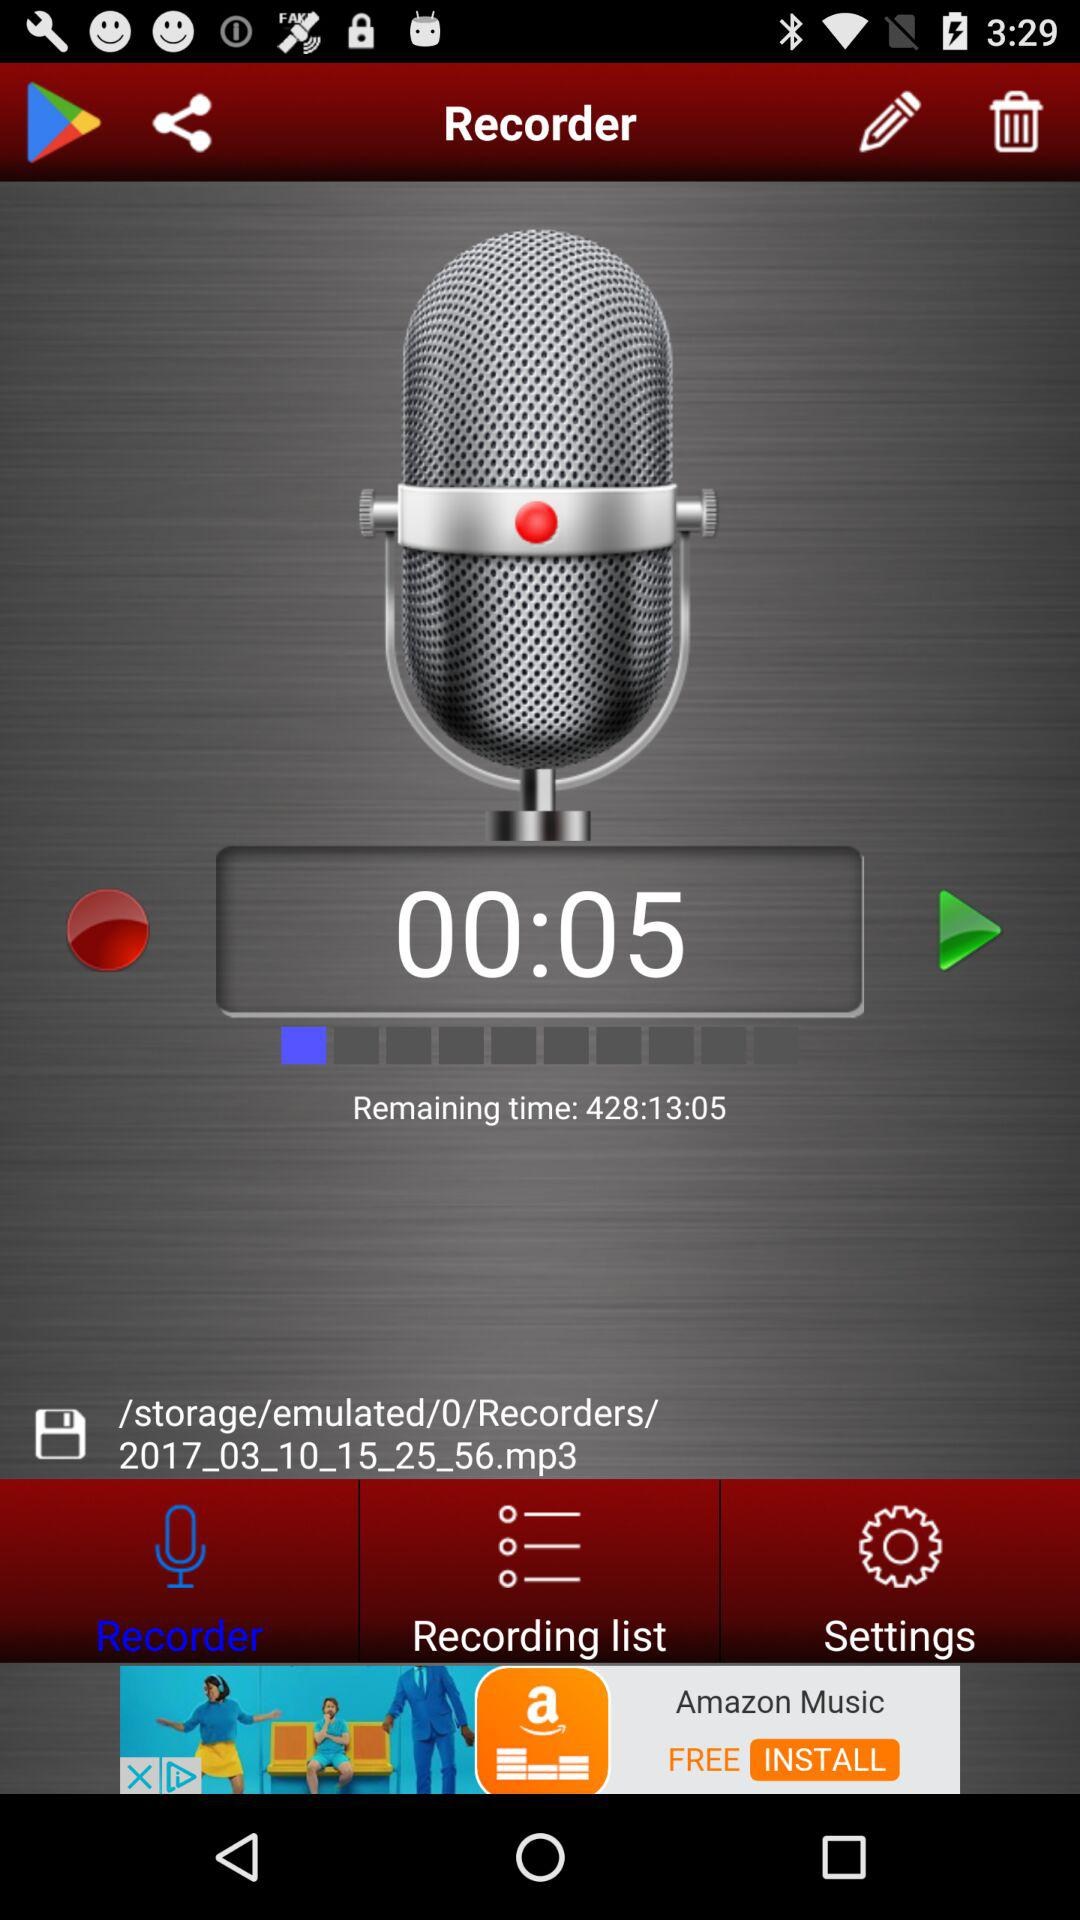Which tab is selected? The selected tab is "Recorder". 